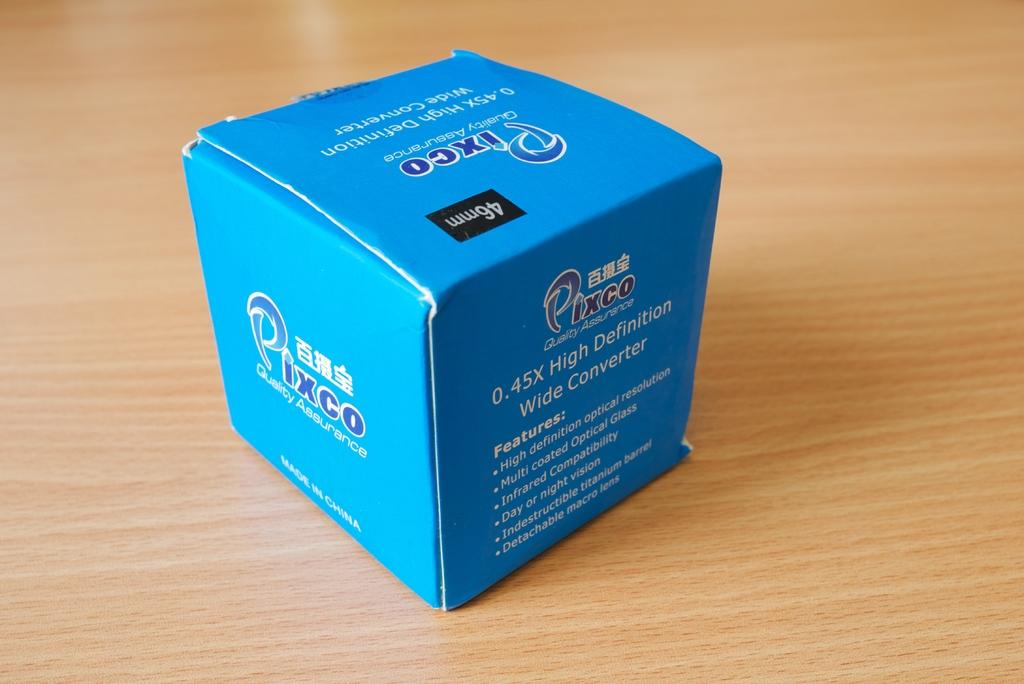<image>
Offer a succinct explanation of the picture presented. a blue box from the brand pixco and in chinese 